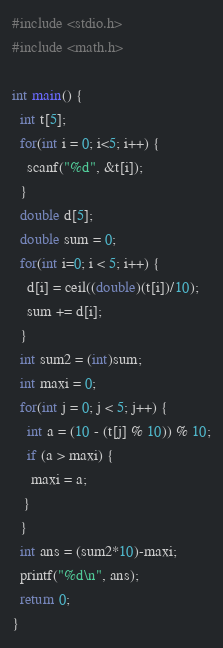<code> <loc_0><loc_0><loc_500><loc_500><_C_>#include <stdio.h>
#include <math.h>

int main() {
  int t[5];
  for(int i = 0; i<5; i++) {
    scanf("%d", &t[i]);
  }
  double d[5];
  double sum = 0;
  for(int i=0; i < 5; i++) {
    d[i] = ceil((double)(t[i])/10);
    sum += d[i];
  }
  int sum2 = (int)sum;
  int maxi = 0;
  for(int j = 0; j < 5; j++) {
    int a = (10 - (t[j] % 10)) % 10;
    if (a > maxi) {
     maxi = a;
   }
  }
  int ans = (sum2*10)-maxi;
  printf("%d\n", ans);
  return 0;
}
</code> 